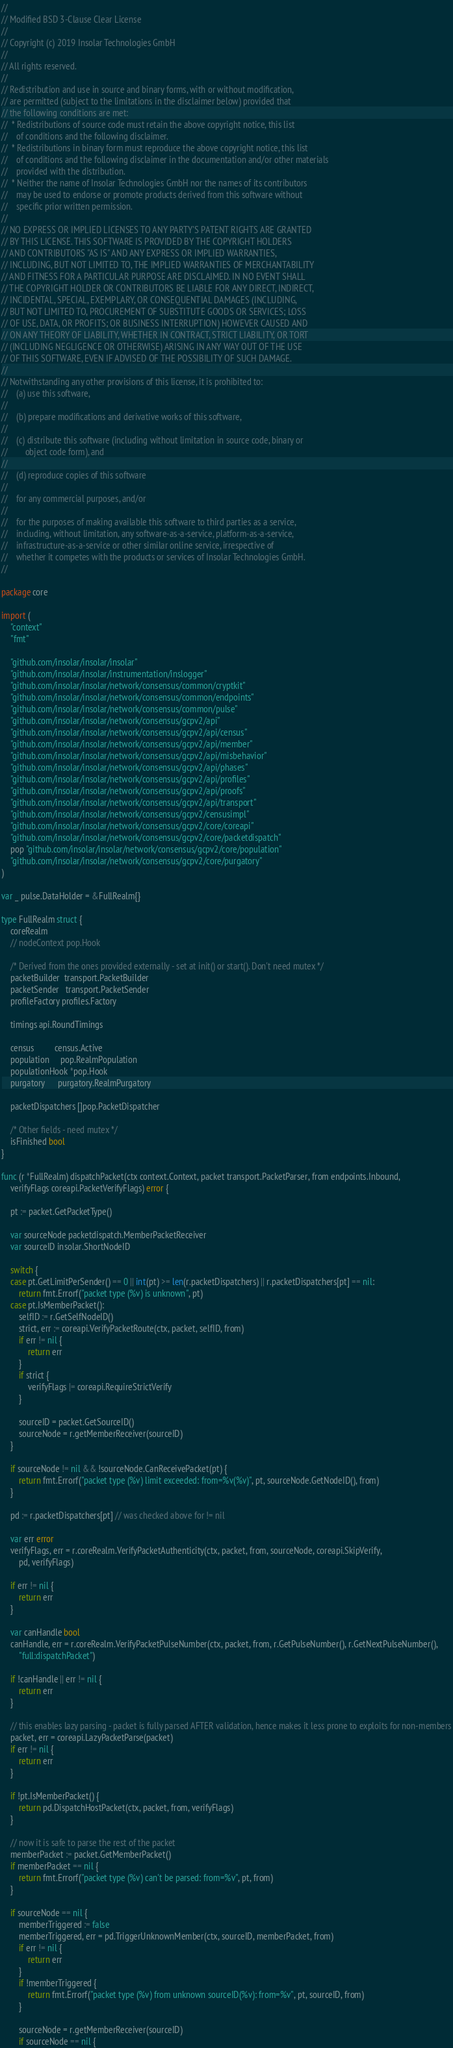<code> <loc_0><loc_0><loc_500><loc_500><_Go_>//
// Modified BSD 3-Clause Clear License
//
// Copyright (c) 2019 Insolar Technologies GmbH
//
// All rights reserved.
//
// Redistribution and use in source and binary forms, with or without modification,
// are permitted (subject to the limitations in the disclaimer below) provided that
// the following conditions are met:
//  * Redistributions of source code must retain the above copyright notice, this list
//    of conditions and the following disclaimer.
//  * Redistributions in binary form must reproduce the above copyright notice, this list
//    of conditions and the following disclaimer in the documentation and/or other materials
//    provided with the distribution.
//  * Neither the name of Insolar Technologies GmbH nor the names of its contributors
//    may be used to endorse or promote products derived from this software without
//    specific prior written permission.
//
// NO EXPRESS OR IMPLIED LICENSES TO ANY PARTY'S PATENT RIGHTS ARE GRANTED
// BY THIS LICENSE. THIS SOFTWARE IS PROVIDED BY THE COPYRIGHT HOLDERS
// AND CONTRIBUTORS "AS IS" AND ANY EXPRESS OR IMPLIED WARRANTIES,
// INCLUDING, BUT NOT LIMITED TO, THE IMPLIED WARRANTIES OF MERCHANTABILITY
// AND FITNESS FOR A PARTICULAR PURPOSE ARE DISCLAIMED. IN NO EVENT SHALL
// THE COPYRIGHT HOLDER OR CONTRIBUTORS BE LIABLE FOR ANY DIRECT, INDIRECT,
// INCIDENTAL, SPECIAL, EXEMPLARY, OR CONSEQUENTIAL DAMAGES (INCLUDING,
// BUT NOT LIMITED TO, PROCUREMENT OF SUBSTITUTE GOODS OR SERVICES; LOSS
// OF USE, DATA, OR PROFITS; OR BUSINESS INTERRUPTION) HOWEVER CAUSED AND
// ON ANY THEORY OF LIABILITY, WHETHER IN CONTRACT, STRICT LIABILITY, OR TORT
// (INCLUDING NEGLIGENCE OR OTHERWISE) ARISING IN ANY WAY OUT OF THE USE
// OF THIS SOFTWARE, EVEN IF ADVISED OF THE POSSIBILITY OF SUCH DAMAGE.
//
// Notwithstanding any other provisions of this license, it is prohibited to:
//    (a) use this software,
//
//    (b) prepare modifications and derivative works of this software,
//
//    (c) distribute this software (including without limitation in source code, binary or
//        object code form), and
//
//    (d) reproduce copies of this software
//
//    for any commercial purposes, and/or
//
//    for the purposes of making available this software to third parties as a service,
//    including, without limitation, any software-as-a-service, platform-as-a-service,
//    infrastructure-as-a-service or other similar online service, irrespective of
//    whether it competes with the products or services of Insolar Technologies GmbH.
//

package core

import (
	"context"
	"fmt"

	"github.com/insolar/insolar/insolar"
	"github.com/insolar/insolar/instrumentation/inslogger"
	"github.com/insolar/insolar/network/consensus/common/cryptkit"
	"github.com/insolar/insolar/network/consensus/common/endpoints"
	"github.com/insolar/insolar/network/consensus/common/pulse"
	"github.com/insolar/insolar/network/consensus/gcpv2/api"
	"github.com/insolar/insolar/network/consensus/gcpv2/api/census"
	"github.com/insolar/insolar/network/consensus/gcpv2/api/member"
	"github.com/insolar/insolar/network/consensus/gcpv2/api/misbehavior"
	"github.com/insolar/insolar/network/consensus/gcpv2/api/phases"
	"github.com/insolar/insolar/network/consensus/gcpv2/api/profiles"
	"github.com/insolar/insolar/network/consensus/gcpv2/api/proofs"
	"github.com/insolar/insolar/network/consensus/gcpv2/api/transport"
	"github.com/insolar/insolar/network/consensus/gcpv2/censusimpl"
	"github.com/insolar/insolar/network/consensus/gcpv2/core/coreapi"
	"github.com/insolar/insolar/network/consensus/gcpv2/core/packetdispatch"
	pop "github.com/insolar/insolar/network/consensus/gcpv2/core/population"
	"github.com/insolar/insolar/network/consensus/gcpv2/core/purgatory"
)

var _ pulse.DataHolder = &FullRealm{}

type FullRealm struct {
	coreRealm
	// nodeContext pop.Hook

	/* Derived from the ones provided externally - set at init() or start(). Don't need mutex */
	packetBuilder  transport.PacketBuilder
	packetSender   transport.PacketSender
	profileFactory profiles.Factory

	timings api.RoundTimings

	census         census.Active
	population     pop.RealmPopulation
	populationHook *pop.Hook
	purgatory      purgatory.RealmPurgatory

	packetDispatchers []pop.PacketDispatcher

	/* Other fields - need mutex */
	isFinished bool
}

func (r *FullRealm) dispatchPacket(ctx context.Context, packet transport.PacketParser, from endpoints.Inbound,
	verifyFlags coreapi.PacketVerifyFlags) error {

	pt := packet.GetPacketType()

	var sourceNode packetdispatch.MemberPacketReceiver
	var sourceID insolar.ShortNodeID

	switch {
	case pt.GetLimitPerSender() == 0 || int(pt) >= len(r.packetDispatchers) || r.packetDispatchers[pt] == nil:
		return fmt.Errorf("packet type (%v) is unknown", pt)
	case pt.IsMemberPacket():
		selfID := r.GetSelfNodeID()
		strict, err := coreapi.VerifyPacketRoute(ctx, packet, selfID, from)
		if err != nil {
			return err
		}
		if strict {
			verifyFlags |= coreapi.RequireStrictVerify
		}

		sourceID = packet.GetSourceID()
		sourceNode = r.getMemberReceiver(sourceID)
	}

	if sourceNode != nil && !sourceNode.CanReceivePacket(pt) {
		return fmt.Errorf("packet type (%v) limit exceeded: from=%v(%v)", pt, sourceNode.GetNodeID(), from)
	}

	pd := r.packetDispatchers[pt] // was checked above for != nil

	var err error
	verifyFlags, err = r.coreRealm.VerifyPacketAuthenticity(ctx, packet, from, sourceNode, coreapi.SkipVerify,
		pd, verifyFlags)

	if err != nil {
		return err
	}

	var canHandle bool
	canHandle, err = r.coreRealm.VerifyPacketPulseNumber(ctx, packet, from, r.GetPulseNumber(), r.GetNextPulseNumber(),
		"full:dispatchPacket")

	if !canHandle || err != nil {
		return err
	}

	// this enables lazy parsing - packet is fully parsed AFTER validation, hence makes it less prone to exploits for non-members
	packet, err = coreapi.LazyPacketParse(packet)
	if err != nil {
		return err
	}

	if !pt.IsMemberPacket() {
		return pd.DispatchHostPacket(ctx, packet, from, verifyFlags)
	}

	// now it is safe to parse the rest of the packet
	memberPacket := packet.GetMemberPacket()
	if memberPacket == nil {
		return fmt.Errorf("packet type (%v) can't be parsed: from=%v", pt, from)
	}

	if sourceNode == nil {
		memberTriggered := false
		memberTriggered, err = pd.TriggerUnknownMember(ctx, sourceID, memberPacket, from)
		if err != nil {
			return err
		}
		if !memberTriggered {
			return fmt.Errorf("packet type (%v) from unknown sourceID(%v): from=%v", pt, sourceID, from)
		}

		sourceNode = r.getMemberReceiver(sourceID)
		if sourceNode == nil {</code> 